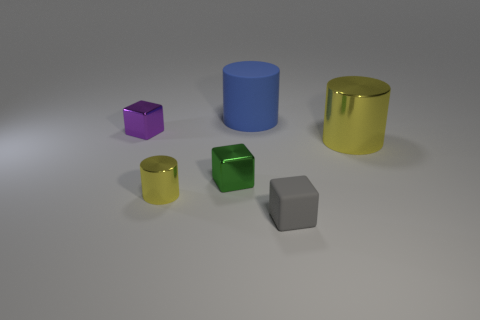Add 2 tiny green rubber cubes. How many objects exist? 8 Subtract all red matte spheres. Subtract all small yellow shiny cylinders. How many objects are left? 5 Add 3 large objects. How many large objects are left? 5 Add 6 yellow metallic things. How many yellow metallic things exist? 8 Subtract 0 red balls. How many objects are left? 6 